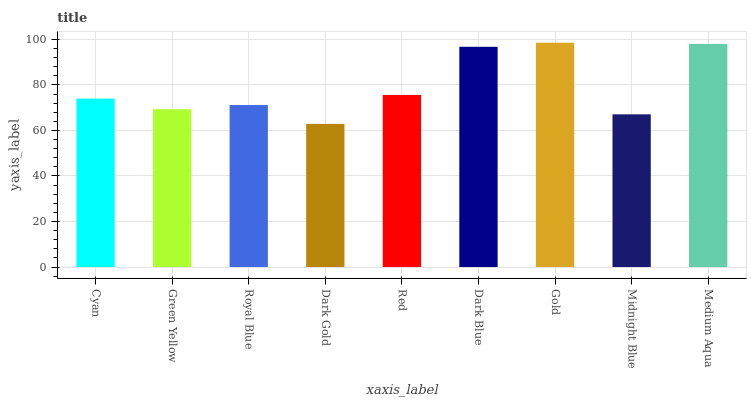Is Dark Gold the minimum?
Answer yes or no. Yes. Is Gold the maximum?
Answer yes or no. Yes. Is Green Yellow the minimum?
Answer yes or no. No. Is Green Yellow the maximum?
Answer yes or no. No. Is Cyan greater than Green Yellow?
Answer yes or no. Yes. Is Green Yellow less than Cyan?
Answer yes or no. Yes. Is Green Yellow greater than Cyan?
Answer yes or no. No. Is Cyan less than Green Yellow?
Answer yes or no. No. Is Cyan the high median?
Answer yes or no. Yes. Is Cyan the low median?
Answer yes or no. Yes. Is Red the high median?
Answer yes or no. No. Is Medium Aqua the low median?
Answer yes or no. No. 